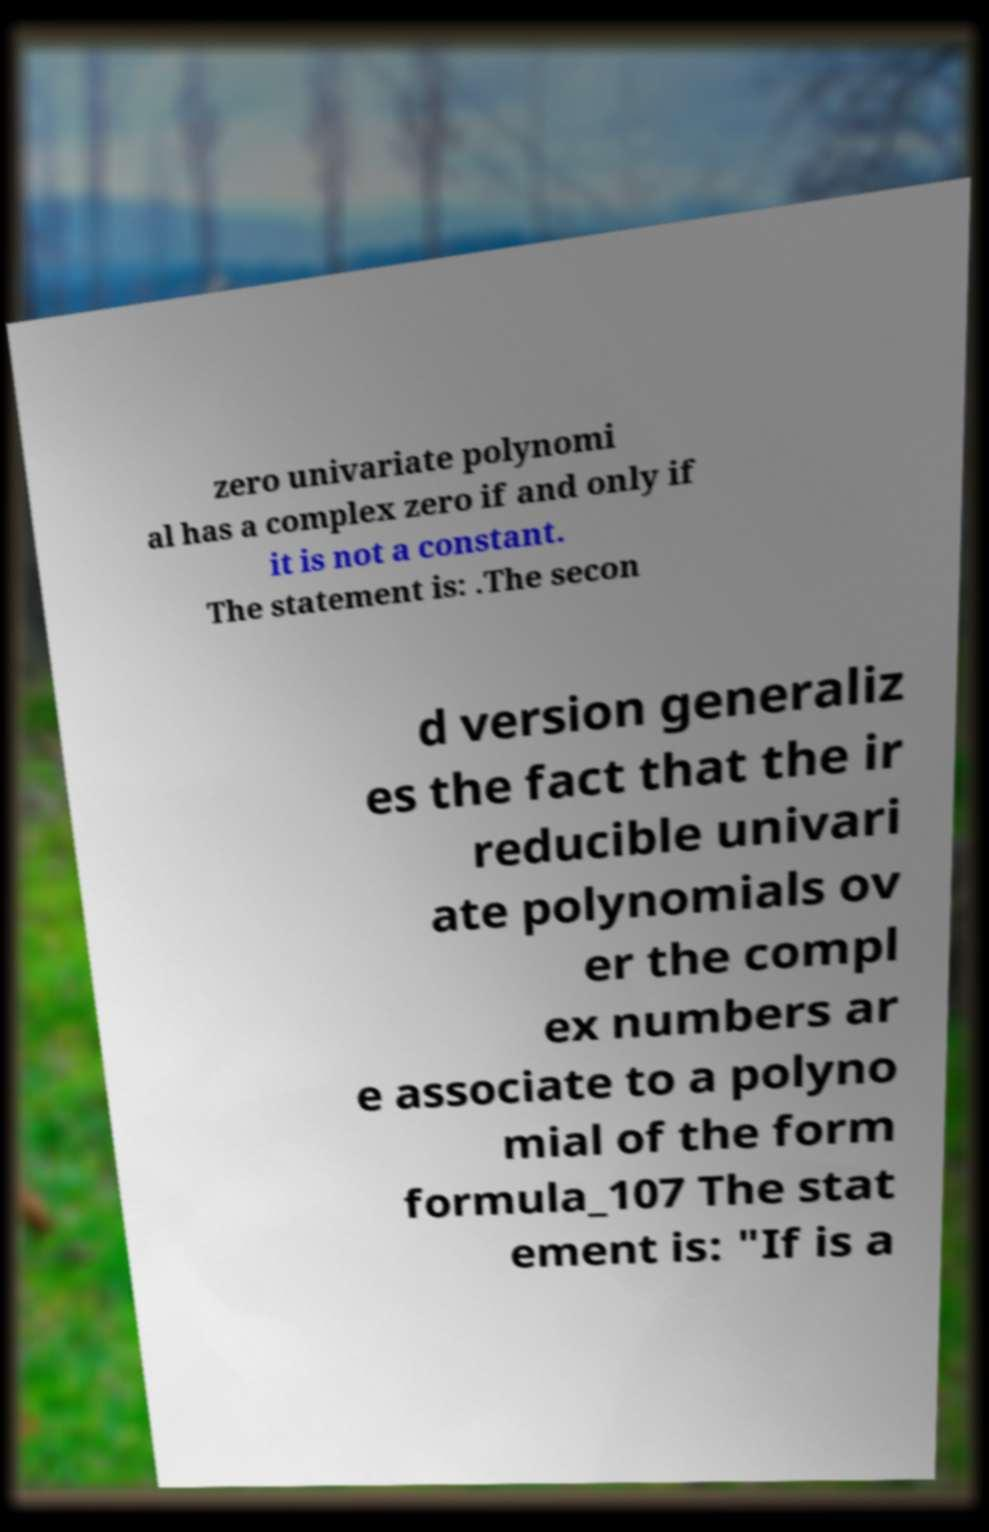Can you read and provide the text displayed in the image?This photo seems to have some interesting text. Can you extract and type it out for me? zero univariate polynomi al has a complex zero if and only if it is not a constant. The statement is: .The secon d version generaliz es the fact that the ir reducible univari ate polynomials ov er the compl ex numbers ar e associate to a polyno mial of the form formula_107 The stat ement is: "If is a 